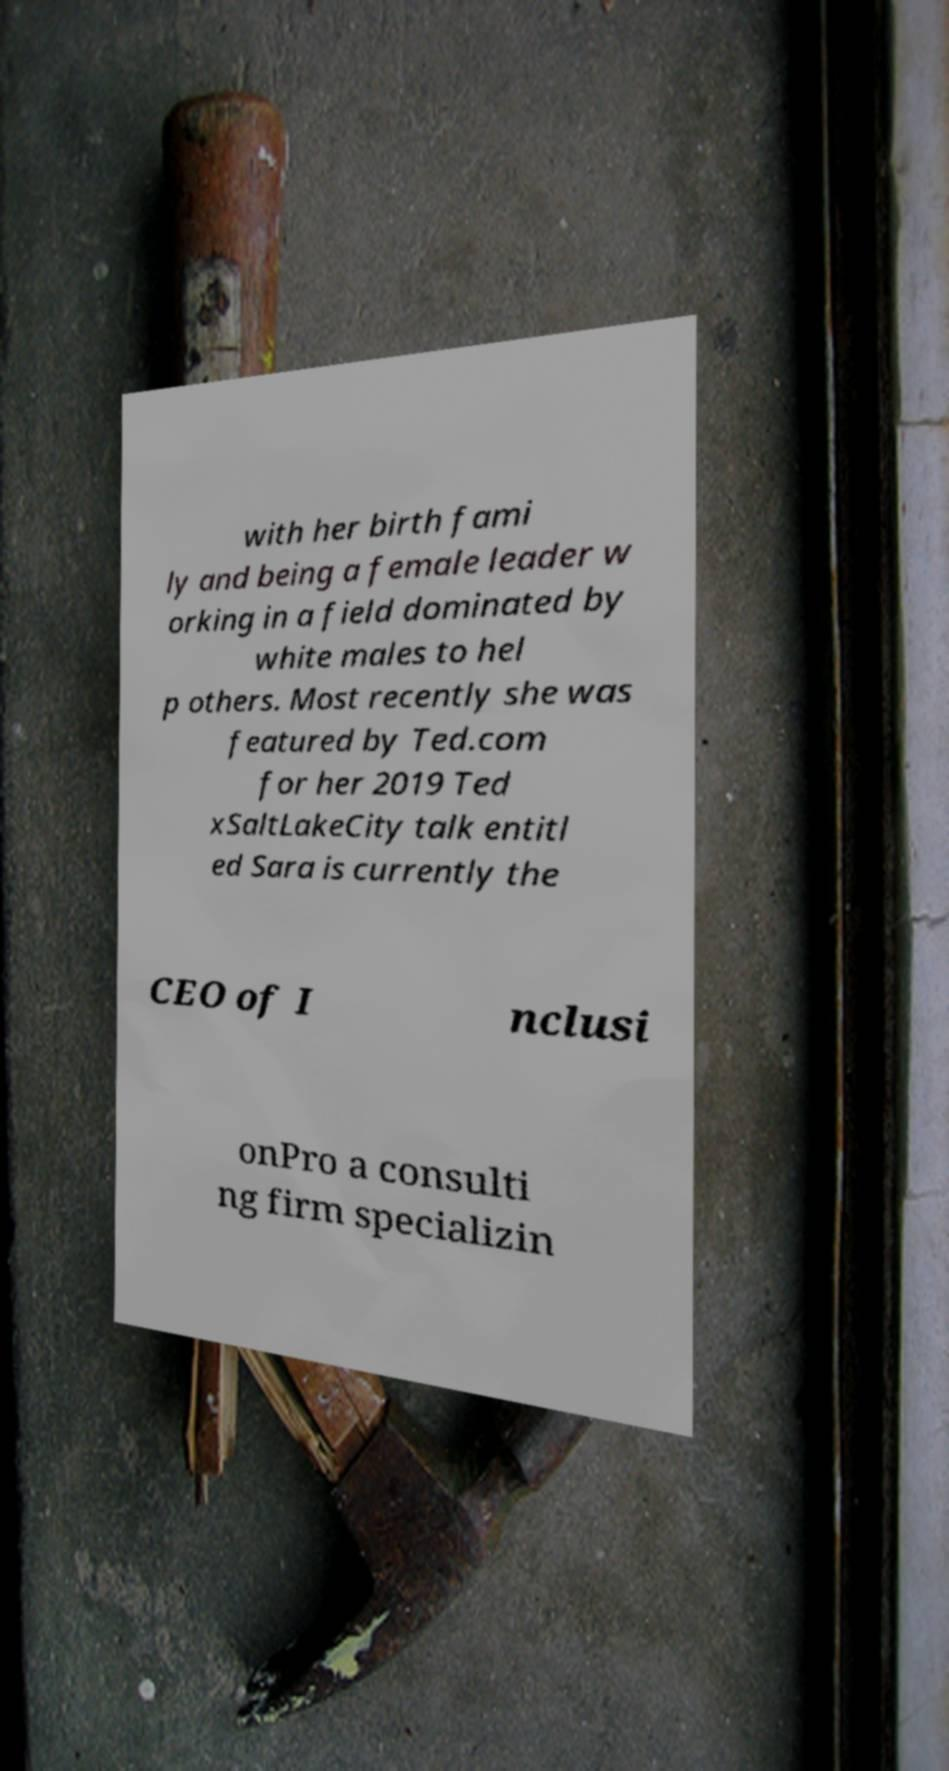For documentation purposes, I need the text within this image transcribed. Could you provide that? with her birth fami ly and being a female leader w orking in a field dominated by white males to hel p others. Most recently she was featured by Ted.com for her 2019 Ted xSaltLakeCity talk entitl ed Sara is currently the CEO of I nclusi onPro a consulti ng firm specializin 